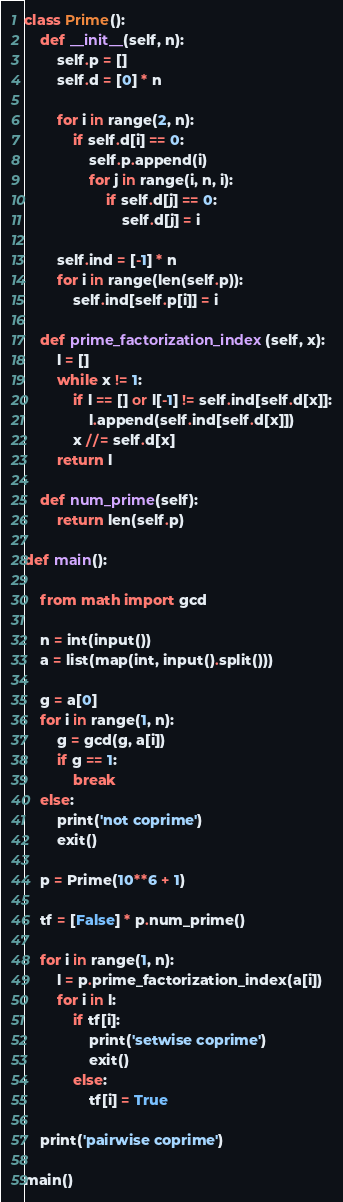<code> <loc_0><loc_0><loc_500><loc_500><_Python_>class Prime():
    def __init__(self, n):
        self.p = []
        self.d = [0] * n

        for i in range(2, n):
            if self.d[i] == 0:
                self.p.append(i)
                for j in range(i, n, i):
                    if self.d[j] == 0:
                        self.d[j] = i

        self.ind = [-1] * n
        for i in range(len(self.p)):
            self.ind[self.p[i]] = i

    def prime_factorization_index(self, x):
        l = []
        while x != 1:
            if l == [] or l[-1] != self.ind[self.d[x]]:
                l.append(self.ind[self.d[x]])
            x //= self.d[x]
        return l

    def num_prime(self):
        return len(self.p)

def main():

    from math import gcd
 
    n = int(input())
    a = list(map(int, input().split()))
 
    g = a[0]
    for i in range(1, n):
        g = gcd(g, a[i])
        if g == 1:
            break
    else:
        print('not coprime')
        exit()

    p = Prime(10**6 + 1)

    tf = [False] * p.num_prime()

    for i in range(1, n):
        l = p.prime_factorization_index(a[i])
        for i in l:
            if tf[i]:
                print('setwise coprime')
                exit()
            else:
                tf[i] = True

    print('pairwise coprime')

main()</code> 